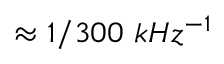<formula> <loc_0><loc_0><loc_500><loc_500>\approx 1 / 3 0 0 k H z ^ { - 1 }</formula> 